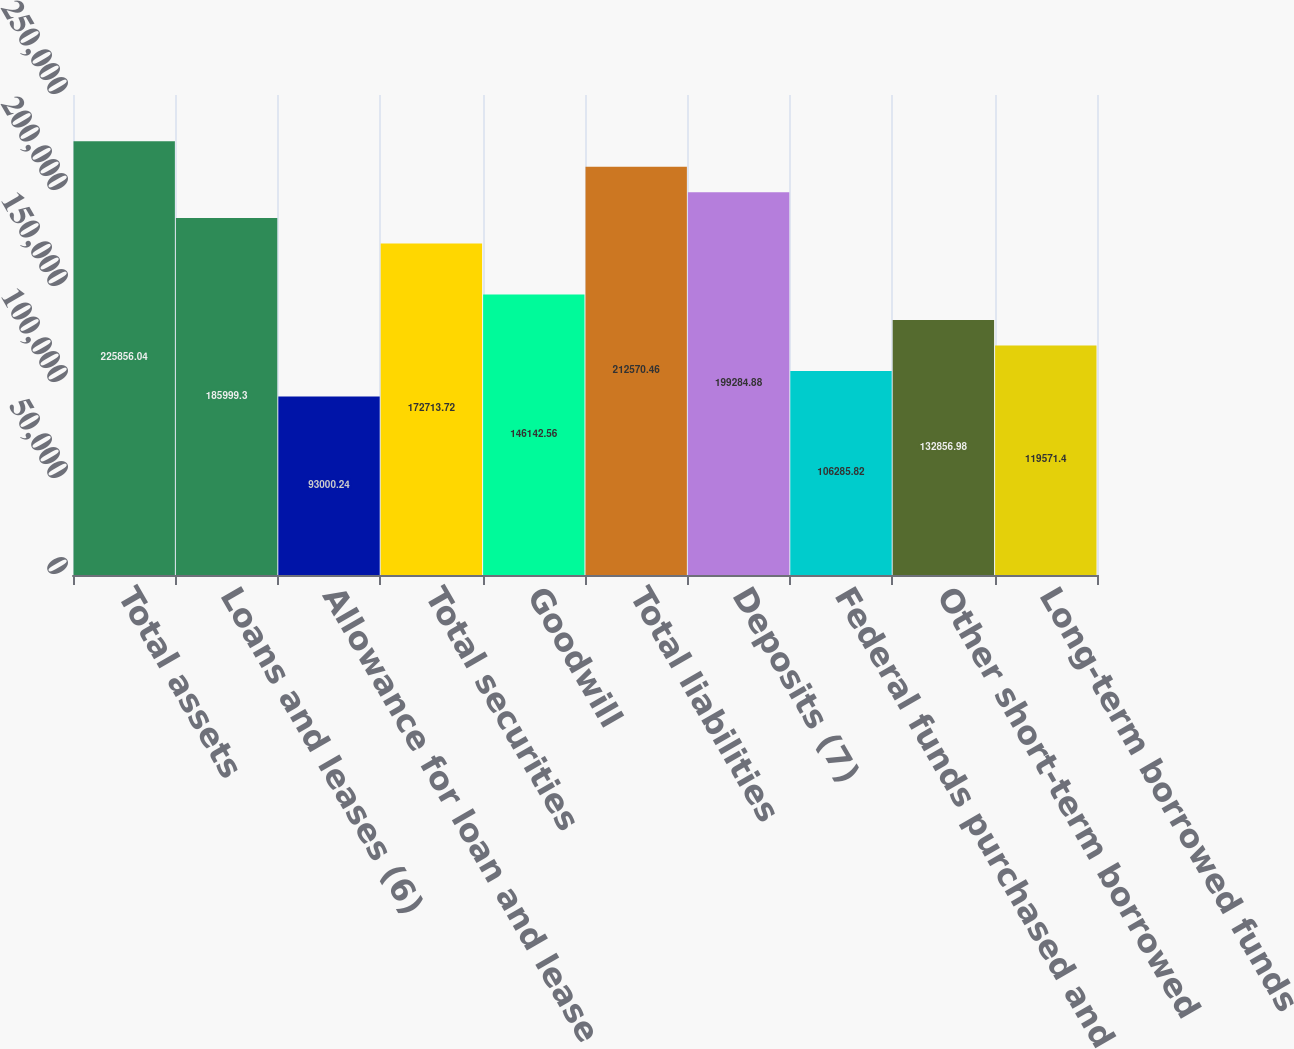Convert chart to OTSL. <chart><loc_0><loc_0><loc_500><loc_500><bar_chart><fcel>Total assets<fcel>Loans and leases (6)<fcel>Allowance for loan and lease<fcel>Total securities<fcel>Goodwill<fcel>Total liabilities<fcel>Deposits (7)<fcel>Federal funds purchased and<fcel>Other short-term borrowed<fcel>Long-term borrowed funds<nl><fcel>225856<fcel>185999<fcel>93000.2<fcel>172714<fcel>146143<fcel>212570<fcel>199285<fcel>106286<fcel>132857<fcel>119571<nl></chart> 